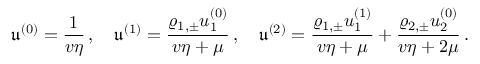<formula> <loc_0><loc_0><loc_500><loc_500>\mathfrak { u } ^ { ( 0 ) } = \frac { 1 } { v \eta } \, , \quad \mathfrak { u } ^ { ( 1 ) } = \frac { \varrho _ { 1 , \pm } u _ { 1 } ^ { ( 0 ) } } { v \eta + \mu } \, , \quad \mathfrak { u } ^ { ( 2 ) } = \frac { \varrho _ { 1 , \pm } u _ { 1 } ^ { ( 1 ) } } { v \eta + \mu } + \frac { \varrho _ { 2 , \pm } u _ { 2 } ^ { ( 0 ) } } { v \eta + 2 \mu } \, .</formula> 